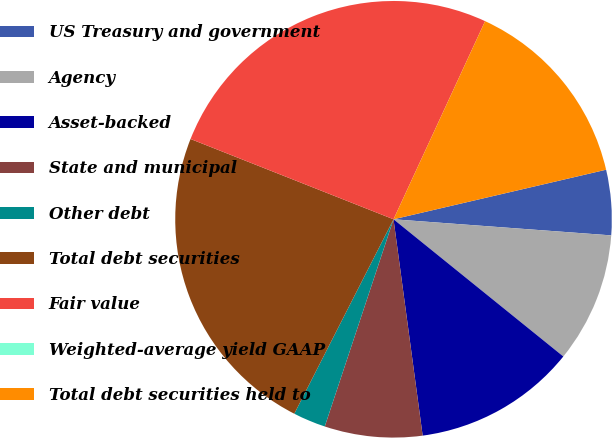Convert chart. <chart><loc_0><loc_0><loc_500><loc_500><pie_chart><fcel>US Treasury and government<fcel>Agency<fcel>Asset-backed<fcel>State and municipal<fcel>Other debt<fcel>Total debt securities<fcel>Fair value<fcel>Weighted-average yield GAAP<fcel>Total debt securities held to<nl><fcel>4.82%<fcel>9.64%<fcel>12.05%<fcel>7.23%<fcel>2.41%<fcel>23.48%<fcel>25.89%<fcel>0.0%<fcel>14.46%<nl></chart> 